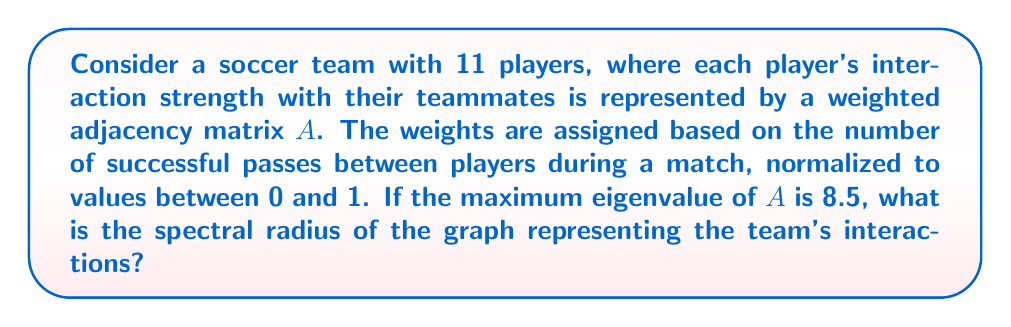Solve this math problem. To solve this problem, we need to understand the following concepts:

1. The adjacency matrix $A$ represents the interactions between players.
2. The spectral radius of a graph is defined as the largest absolute value of the eigenvalues of its adjacency matrix.

Step 1: Identify the given information
- The team has 11 players
- The adjacency matrix $A$ is weighted based on successful passes
- Weights are normalized between 0 and 1
- The maximum eigenvalue of $A$ is 8.5

Step 2: Determine the spectral radius
The spectral radius $\rho(A)$ is given by:

$$\rho(A) = \max\{|\lambda_i| : \lambda_i \text{ is an eigenvalue of } A\}$$

Since we are given that the maximum eigenvalue is 8.5, and all weights are non-negative (between 0 and 1), we can conclude that 8.5 is the largest absolute value among all eigenvalues.

Therefore, the spectral radius of the graph is 8.5.

This value indicates the overall connectivity and interaction strength within the team. A higher spectral radius suggests stronger and more frequent interactions between players, which could be interpreted as better team cohesion and passing ability.
Answer: 8.5 